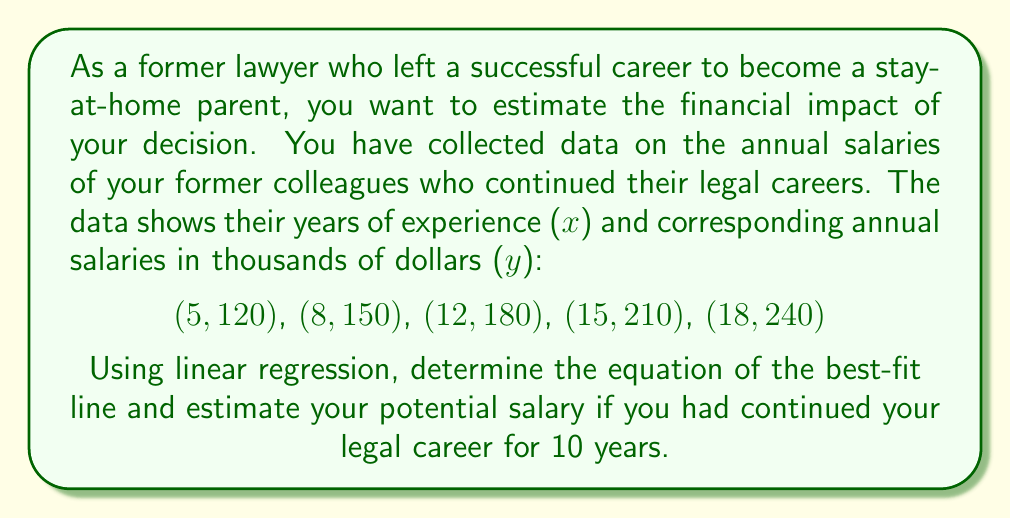Solve this math problem. 1. To find the linear regression equation, we'll use the formula:
   $y = mx + b$
   where $m$ is the slope and $b$ is the y-intercept.

2. Calculate the means of x and y:
   $\bar{x} = \frac{5 + 8 + 12 + 15 + 18}{5} = 11.6$
   $\bar{y} = \frac{120 + 150 + 180 + 210 + 240}{5} = 180$

3. Calculate the slope (m):
   $m = \frac{\sum(x_i - \bar{x})(y_i - \bar{y})}{\sum(x_i - \bar{x})^2}$

   $\sum(x_i - \bar{x})(y_i - \bar{y}) = (-6.6)(-60) + (-3.6)(-30) + (0.4)(0) + (3.4)(30) + (6.4)(60) = 594$

   $\sum(x_i - \bar{x})^2 = (-6.6)^2 + (-3.6)^2 + (0.4)^2 + (3.4)^2 + (6.4)^2 = 118.24$

   $m = \frac{594}{118.24} = 5.024$

4. Calculate the y-intercept (b):
   $b = \bar{y} - m\bar{x} = 180 - (5.024)(11.6) = 121.72$

5. The linear regression equation is:
   $y = 5.024x + 121.72$

6. To estimate the salary after 10 years, substitute x = 10:
   $y = 5.024(10) + 121.72 = 171.96$

Therefore, the estimated salary after 10 years would be approximately $171,960.
Answer: $171,960 